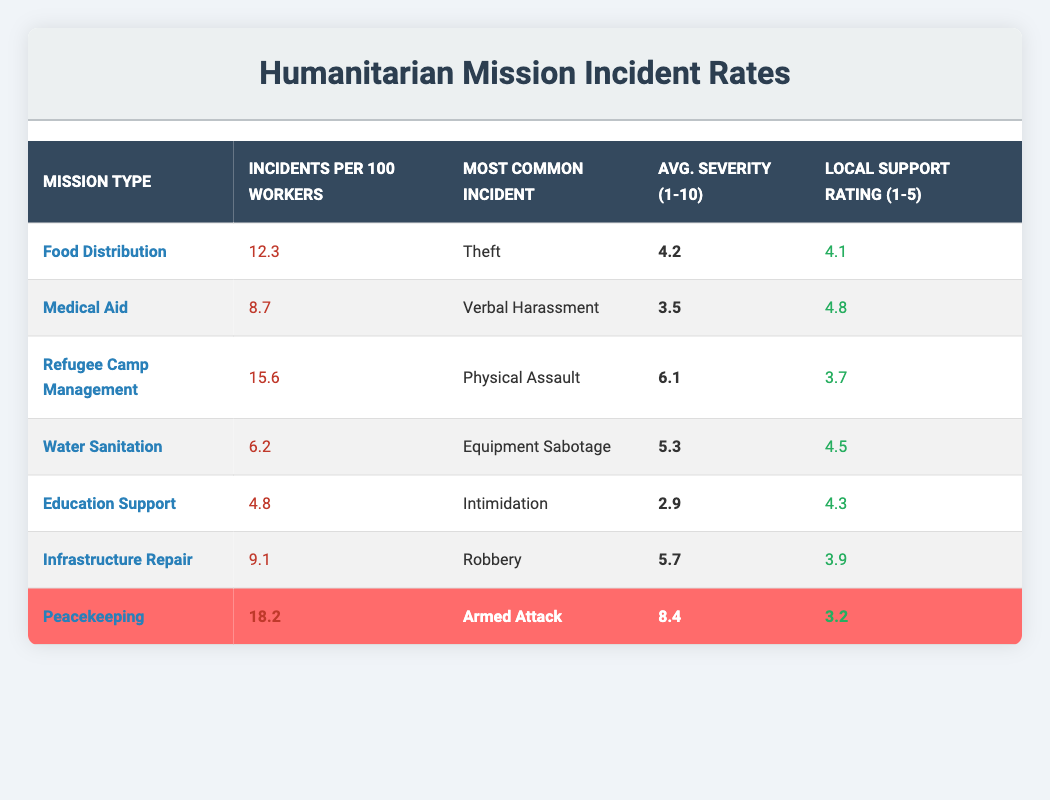What is the most common incident for Food Distribution missions? According to the table, the most common incident listed under Food Distribution is "Theft."
Answer: Theft Which mission type has the highest incident rate per 100 workers? The table shows that "Peacekeeping" has the highest incident rate at 18.2 incidents per 100 workers.
Answer: Peacekeeping What is the average severity rating for incidents in Refugee Camp Management? The average severity rating listed for incidents in Refugee Camp Management is 6.1 on a scale of 1 to 10.
Answer: 6.1 Is the Local Support Rating for Medical Aid higher than that for Infrastructure Repair? The table indicates that the Local Support Rating for Medical Aid is 4.8, while for Infrastructure Repair it is 3.9. Since 4.8 is greater than 3.9, the answer is yes.
Answer: Yes What is the average number of incidents per 100 workers across all mission types? To find the average, sum all incidents: 12.3 (Food Distribution) + 8.7 (Medical Aid) + 15.6 (Refugee Camp Management) + 6.2 (Water Sanitation) + 4.8 (Education Support) + 9.1 (Infrastructure Repair) + 18.2 (Peacekeeping) = 75.9. There are 7 mission types, so the average is 75.9 / 7 = approximately 10.84.
Answer: 10.84 Which mission type has the lowest number of incidents per 100 workers? From the table, "Education Support" has the lowest figure, with only 4.8 incidents per 100 workers.
Answer: Education Support 